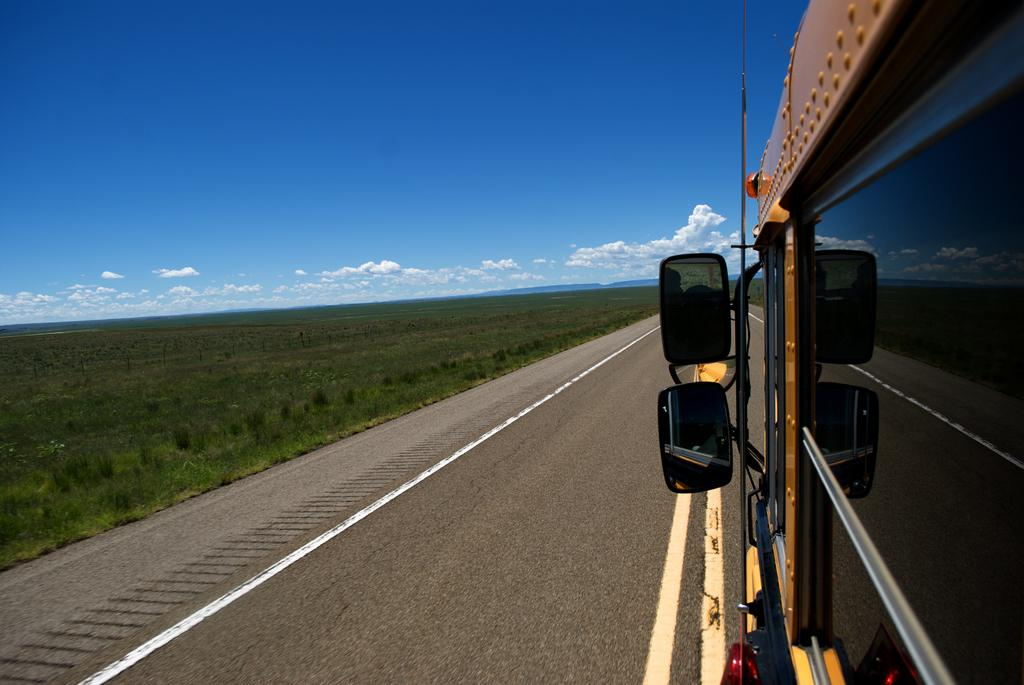What type of vehicle is in the image? There is a vehicle in the image, but the specific type is not mentioned in the facts. What objects in the image are reflective? There are mirrors in the image that are reflective. What type of window is present in the image? There is a glass window in the image. What are the rods used for in the image? The purpose of the rods in the image is not mentioned in the facts. What type of vegetation is visible in the image? There is green grass visible in the image. What is the color of the sky in the image? The sky is blue and white in color. Where are the dolls playing in the image? There are no dolls present in the image. What type of drink is being served in the image? There is no mention of any drink, such as eggnog, in the image. 